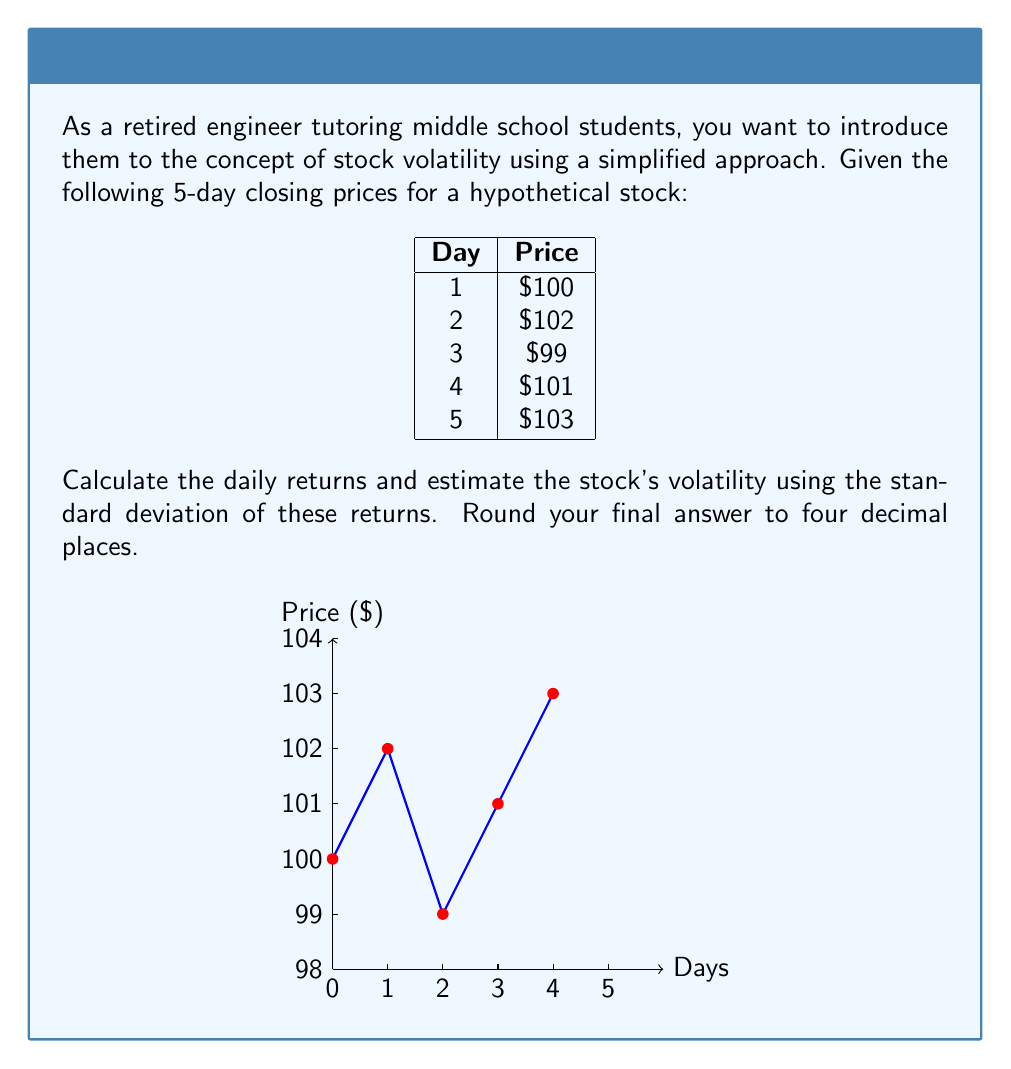Help me with this question. Let's approach this step-by-step:

1) First, calculate the daily returns. The daily return is the percentage change from one day to the next:

   $R_t = \frac{P_t - P_{t-1}}{P_{t-1}}$

   Day 2: $R_2 = \frac{102 - 100}{100} = 0.02$ or 2%
   Day 3: $R_3 = \frac{99 - 102}{102} \approx -0.0294$ or -2.94%
   Day 4: $R_4 = \frac{101 - 99}{99} \approx 0.0202$ or 2.02%
   Day 5: $R_5 = \frac{103 - 101}{101} \approx 0.0198$ or 1.98%

2) Calculate the mean of these returns:
   $\bar{R} = \frac{0.02 + (-0.0294) + 0.0202 + 0.0198}{4} \approx 0.00765$

3) Calculate the squared differences from the mean:
   $(0.02 - 0.00765)^2 \approx 0.000153$
   $(-0.0294 - 0.00765)^2 \approx 0.001369$
   $(0.0202 - 0.00765)^2 \approx 0.000158$
   $(0.0198 - 0.00765)^2 \approx 0.000147$

4) Calculate the variance by taking the average of these squared differences:
   $\sigma^2 = \frac{0.000153 + 0.001369 + 0.000158 + 0.000147}{4} \approx 0.000457$

5) The volatility is the square root of the variance:
   $\sigma = \sqrt{0.000457} \approx 0.0214$

6) Convert to percentage and round to four decimal places:
   $0.0214 * 100 \approx 2.1400\%$
Answer: 2.1400% 